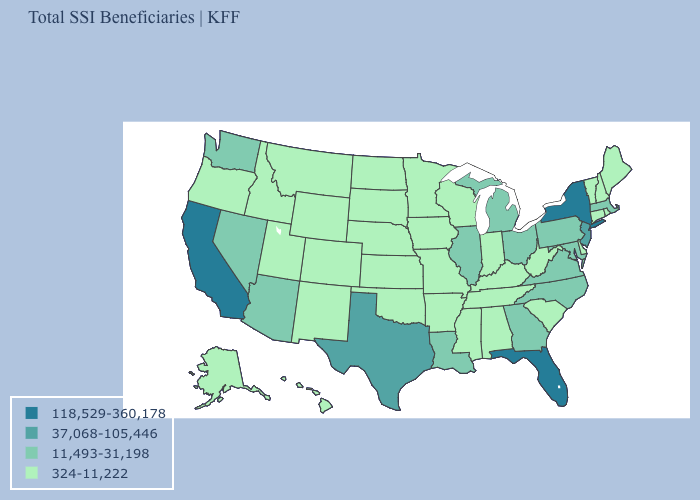Is the legend a continuous bar?
Keep it brief. No. Does Montana have a lower value than South Carolina?
Give a very brief answer. No. What is the value of Hawaii?
Give a very brief answer. 324-11,222. Does the first symbol in the legend represent the smallest category?
Give a very brief answer. No. What is the value of North Dakota?
Give a very brief answer. 324-11,222. What is the value of Delaware?
Concise answer only. 324-11,222. What is the value of Iowa?
Give a very brief answer. 324-11,222. Does Kansas have the same value as Arkansas?
Concise answer only. Yes. What is the value of Iowa?
Be succinct. 324-11,222. Name the states that have a value in the range 11,493-31,198?
Concise answer only. Arizona, Georgia, Illinois, Louisiana, Maryland, Massachusetts, Michigan, Nevada, North Carolina, Ohio, Pennsylvania, Virginia, Washington. Among the states that border New York , does Connecticut have the lowest value?
Answer briefly. Yes. Name the states that have a value in the range 324-11,222?
Give a very brief answer. Alabama, Alaska, Arkansas, Colorado, Connecticut, Delaware, Hawaii, Idaho, Indiana, Iowa, Kansas, Kentucky, Maine, Minnesota, Mississippi, Missouri, Montana, Nebraska, New Hampshire, New Mexico, North Dakota, Oklahoma, Oregon, Rhode Island, South Carolina, South Dakota, Tennessee, Utah, Vermont, West Virginia, Wisconsin, Wyoming. Among the states that border New York , does Pennsylvania have the lowest value?
Concise answer only. No. What is the value of Washington?
Keep it brief. 11,493-31,198. Which states have the lowest value in the USA?
Write a very short answer. Alabama, Alaska, Arkansas, Colorado, Connecticut, Delaware, Hawaii, Idaho, Indiana, Iowa, Kansas, Kentucky, Maine, Minnesota, Mississippi, Missouri, Montana, Nebraska, New Hampshire, New Mexico, North Dakota, Oklahoma, Oregon, Rhode Island, South Carolina, South Dakota, Tennessee, Utah, Vermont, West Virginia, Wisconsin, Wyoming. 